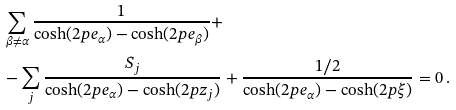Convert formula to latex. <formula><loc_0><loc_0><loc_500><loc_500>& \sum _ { \beta \neq \alpha } \frac { 1 } { \cosh ( 2 p e _ { \alpha } ) - \cosh ( 2 p e _ { \beta } ) } + \\ & - \sum _ { j } \frac { S _ { j } } { \cosh ( 2 p e _ { \alpha } ) - \cosh ( 2 p z _ { j } ) } + \frac { 1 / 2 } { \cosh ( 2 p e _ { \alpha } ) - \cosh ( 2 p \xi ) } = 0 \, .</formula> 